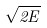<formula> <loc_0><loc_0><loc_500><loc_500>\sqrt { 2 E }</formula> 